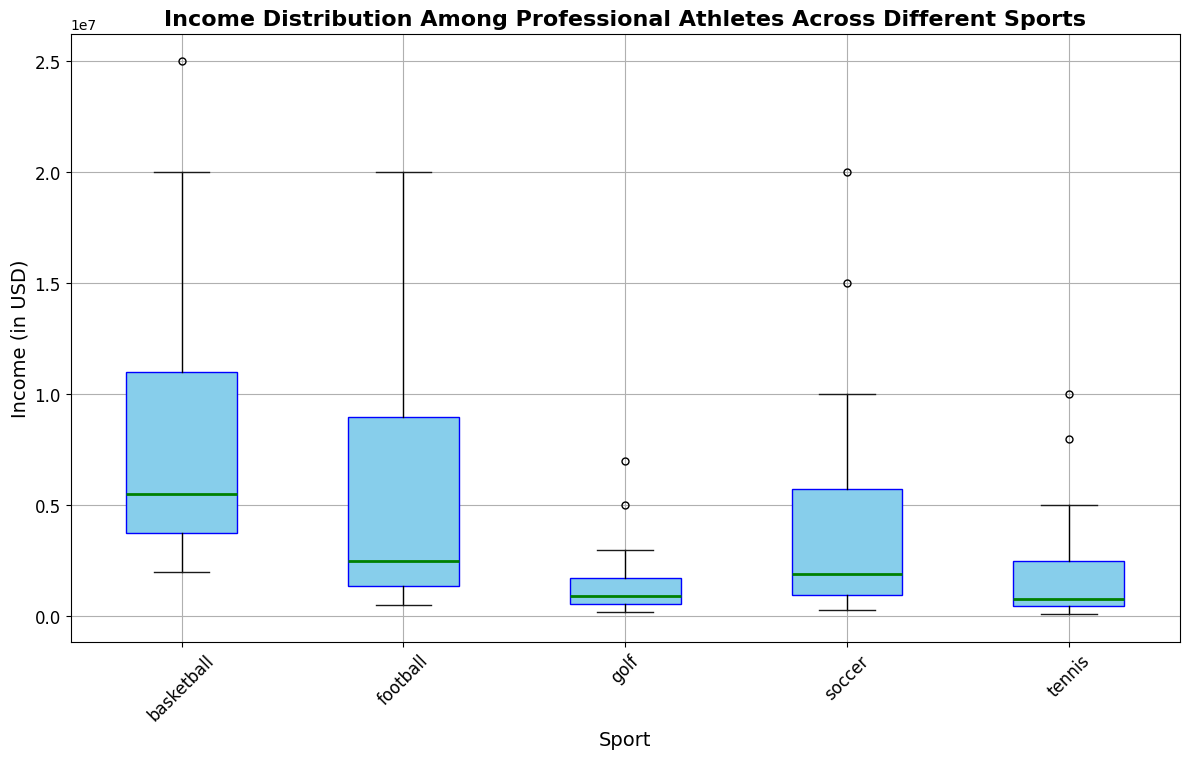Which sport has the highest median income? By observing the green lines, which indicate the median income for each sport, we can see that basketball has the highest median income.
Answer: basketball Which sport has the lowest median income? By observing the green lines, which indicate the median income for each sport, we can see that tennis has the lowest median income.
Answer: tennis Which sport shows the widest range of incomes? The range of incomes is indicated by the distance between the whiskers (the black lines). Basketball shows the widest range of incomes.
Answer: basketball How does the median income of soccer compare to that of football? The green line for soccer is slightly above the green line for football, indicating that soccer's median income is higher than that of football.
Answer: Soccer's median income is higher than football's What is the interquartile range (IQR) for golf? The IQR is the distance between the top and bottom of the box. For golf, the box spans from 400,000 to 3,000,000, so the IQR is 3,000,000 - 400,000.
Answer: 2,600,000 Which sport has the most outliers in income? Outliers are represented by the red markers outside the whiskers. Basketball has the most outliers.
Answer: basketball Is there any overlap in the interquartile ranges of soccer and tennis? By observing the boxes for soccer and tennis, we see that there is no overlap between their interquartile ranges; soccer's box is higher.
Answer: No What visual attribute identifies the median incomes in the plot? The median incomes are indicated by the green lines within each box.
Answer: green lines How does the upper quartile income of tennis compare to the median income of football? The upper edge of the tennis box is higher compared to the median line of the football box.
Answer: The upper quartile income of tennis is higher than the median income of football Considering the box for basketball, what can be said about the income distribution spread when compared with tennis? The spread of the income distribution in basketball, indicated by the height of the box and whiskers, is much greater than in tennis.
Answer: Basketball's spread is much greater than tennis's 